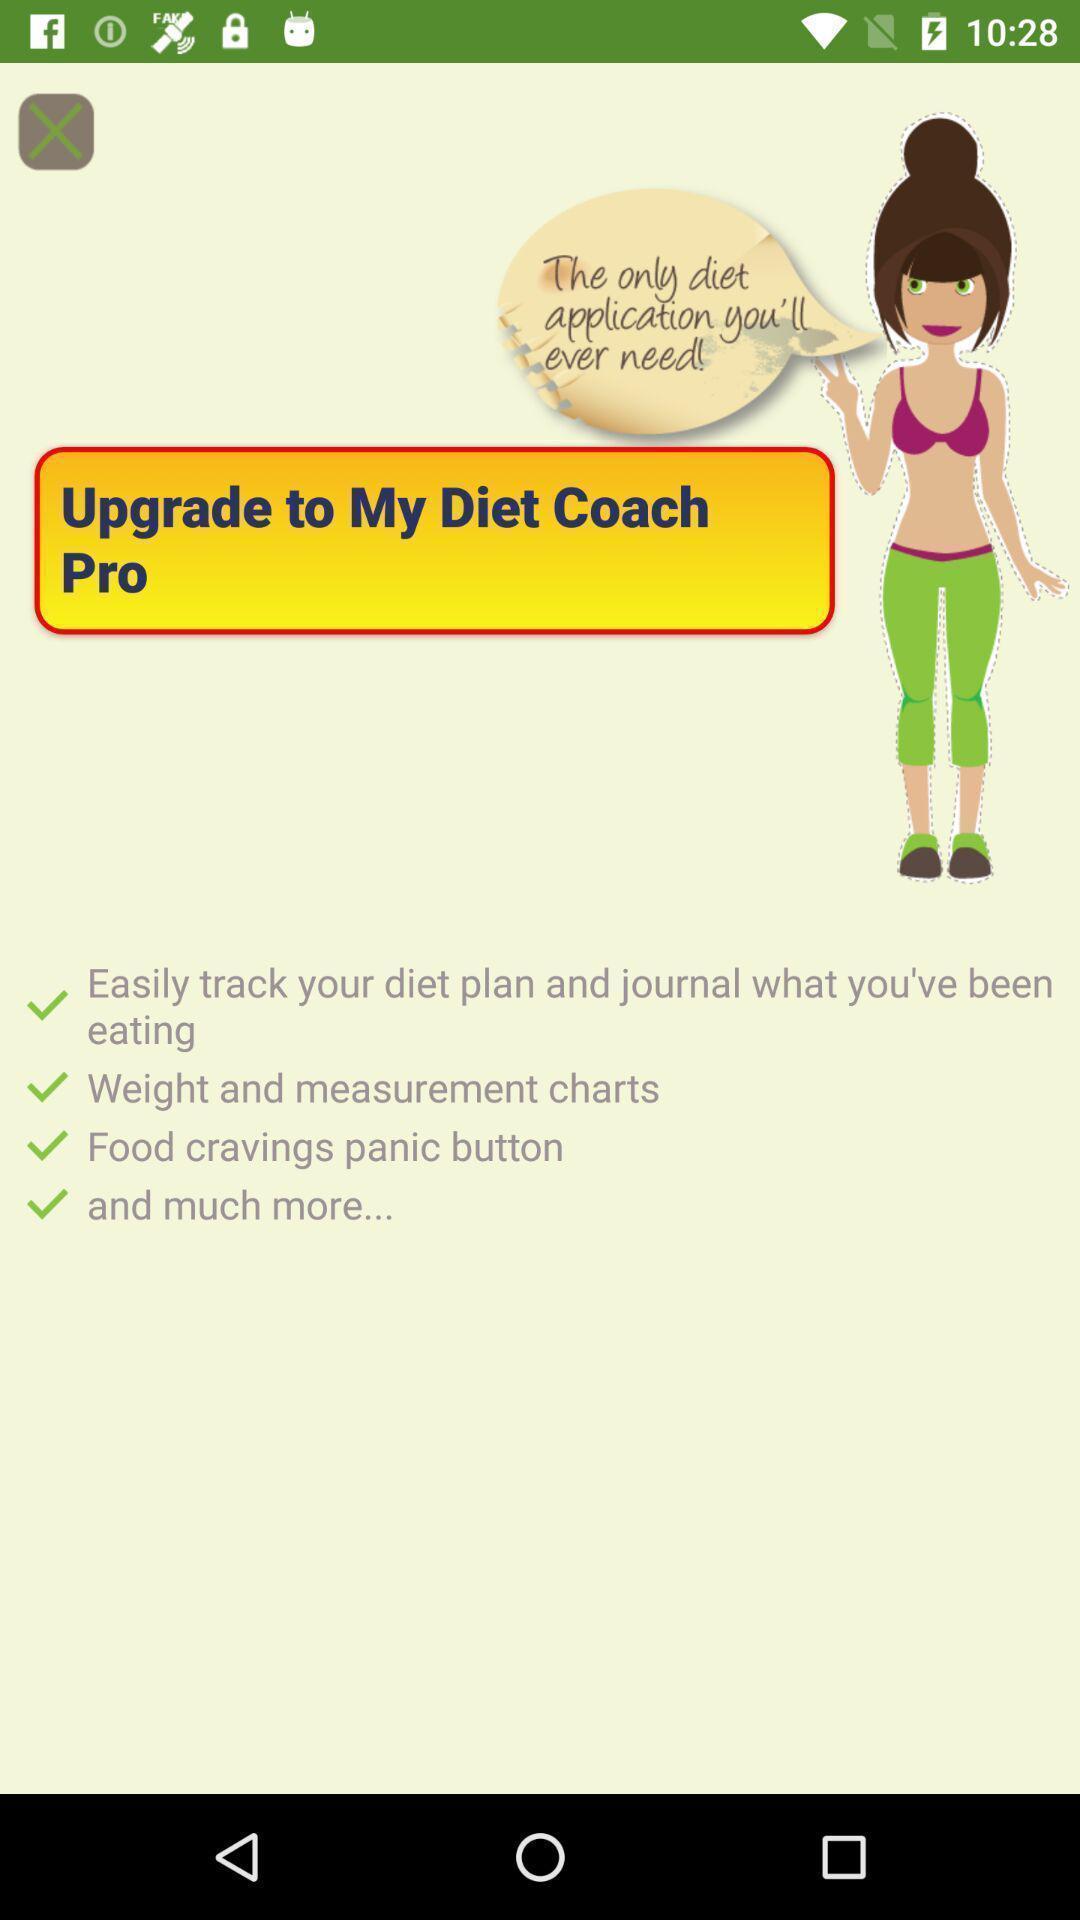Provide a textual representation of this image. Screen display various options in fitness app. 